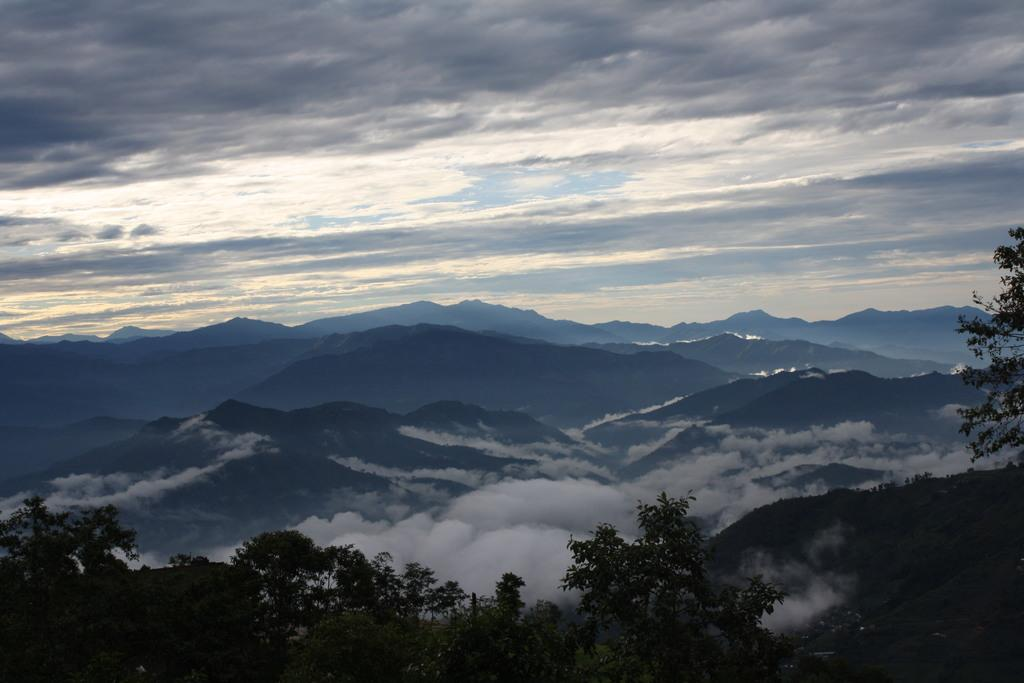What can be seen on the mountains in the image? There are trees and smoke on the mountains in the image. What is visible in the sky in the background? In the background, there are clouds in the sky. What type of square can be seen on the mountains in the image? There is no square present on the mountains in the image. What kind of trouble is depicted in the image? The image does not depict any trouble; it shows trees, smoke, and clouds. 